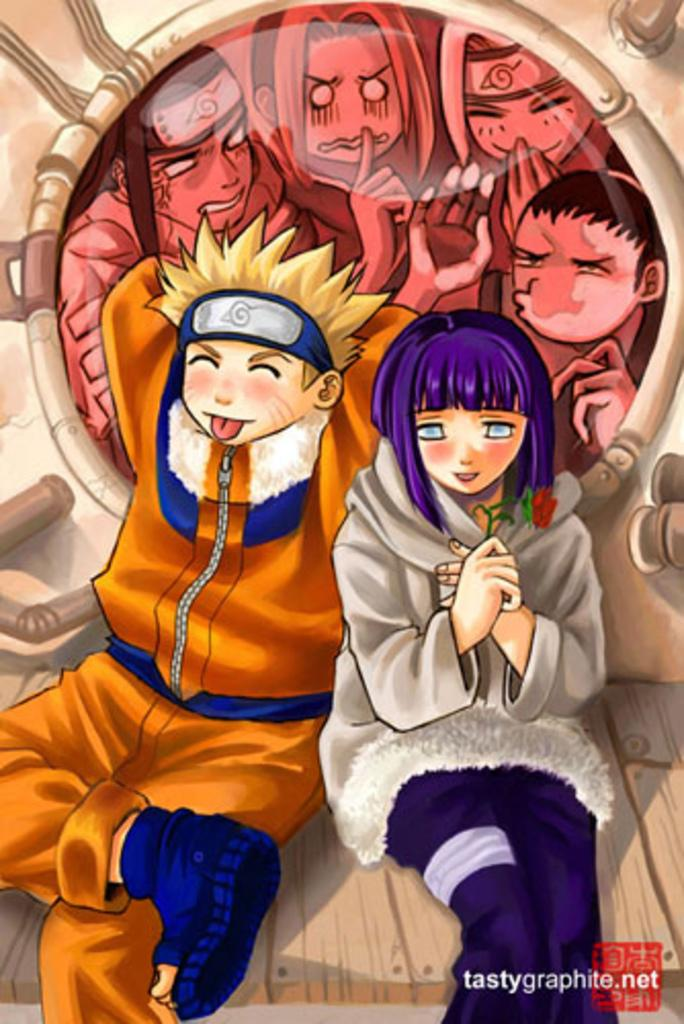What type of images are present in the picture? There are cartoon images in the picture. Where can you find text in the image? The text is located in the bottom right-hand corner of the image. What type of pets are featured in the cartoon images? There is no information about pets in the image; it only contains cartoon images and text. 